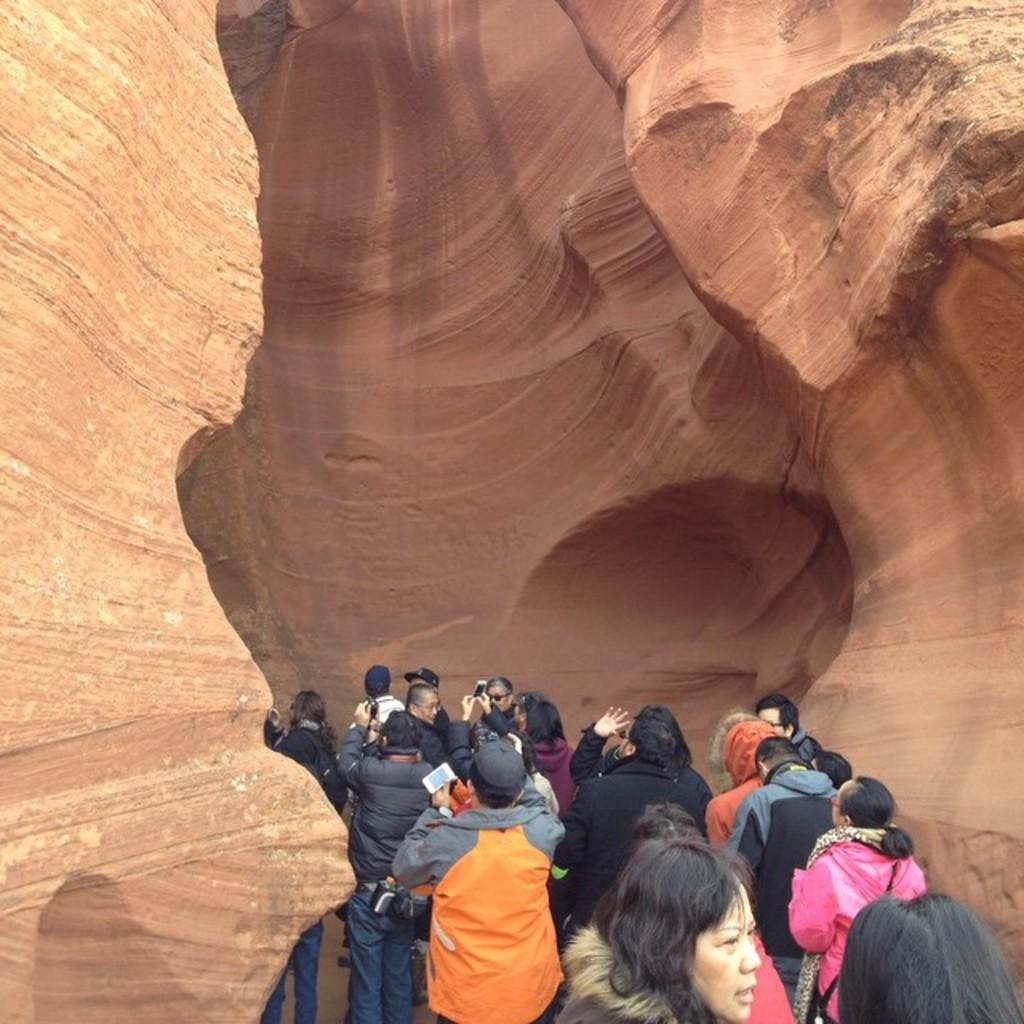How many people are in the image? There is a group of people in the image. What are the people in the image doing? The people are standing. What can be seen in the background of the image? There is a canyon in the background of the image. What list can be seen in the hands of the people in the image? There is no list present in the image; the people are standing without any visible objects in their hands. 